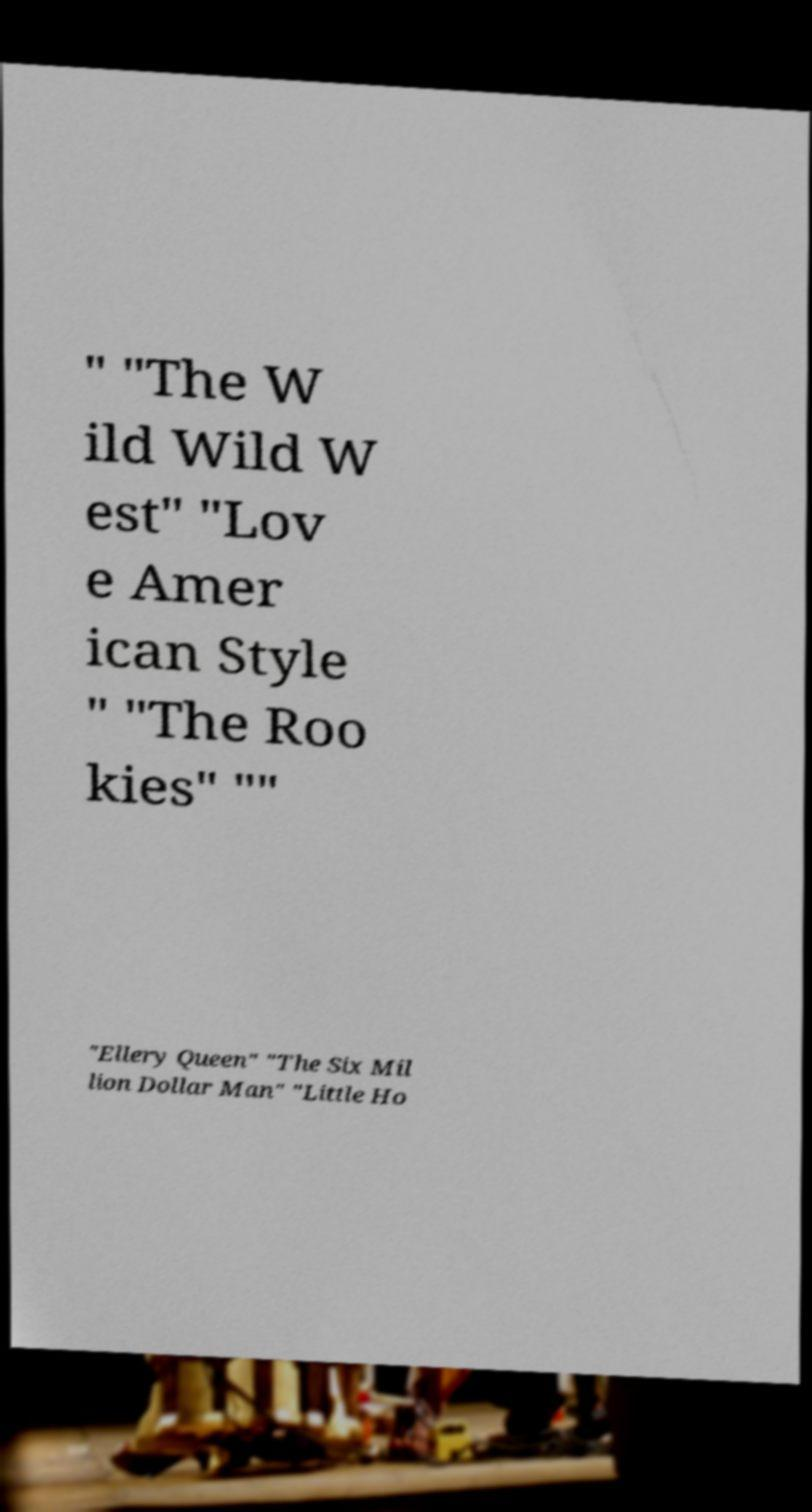Please read and relay the text visible in this image. What does it say? " "The W ild Wild W est" "Lov e Amer ican Style " "The Roo kies" "" "Ellery Queen" "The Six Mil lion Dollar Man" "Little Ho 